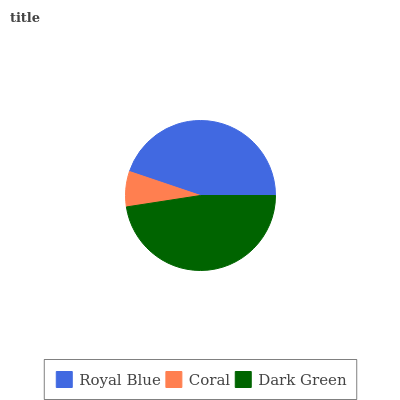Is Coral the minimum?
Answer yes or no. Yes. Is Dark Green the maximum?
Answer yes or no. Yes. Is Dark Green the minimum?
Answer yes or no. No. Is Coral the maximum?
Answer yes or no. No. Is Dark Green greater than Coral?
Answer yes or no. Yes. Is Coral less than Dark Green?
Answer yes or no. Yes. Is Coral greater than Dark Green?
Answer yes or no. No. Is Dark Green less than Coral?
Answer yes or no. No. Is Royal Blue the high median?
Answer yes or no. Yes. Is Royal Blue the low median?
Answer yes or no. Yes. Is Dark Green the high median?
Answer yes or no. No. Is Coral the low median?
Answer yes or no. No. 